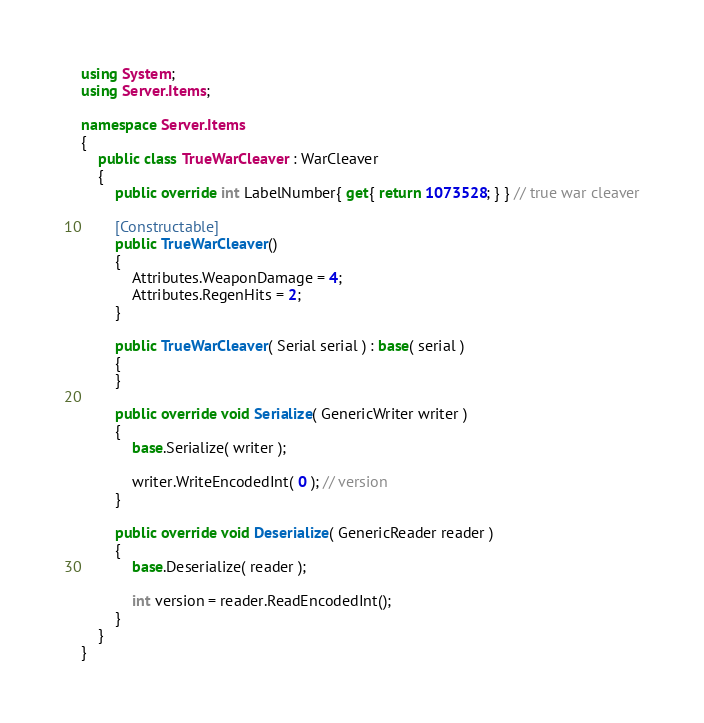<code> <loc_0><loc_0><loc_500><loc_500><_C#_>using System;
using Server.Items;

namespace Server.Items
{
	public class TrueWarCleaver : WarCleaver
	{
		public override int LabelNumber{ get{ return 1073528; } } // true war cleaver

		[Constructable]
		public TrueWarCleaver()
		{
			Attributes.WeaponDamage = 4;
			Attributes.RegenHits = 2;
		}

		public TrueWarCleaver( Serial serial ) : base( serial )
		{
		}

		public override void Serialize( GenericWriter writer )
		{
			base.Serialize( writer );

			writer.WriteEncodedInt( 0 ); // version
		}

		public override void Deserialize( GenericReader reader )
		{
			base.Deserialize( reader );

			int version = reader.ReadEncodedInt();
		}
	}
}
</code> 